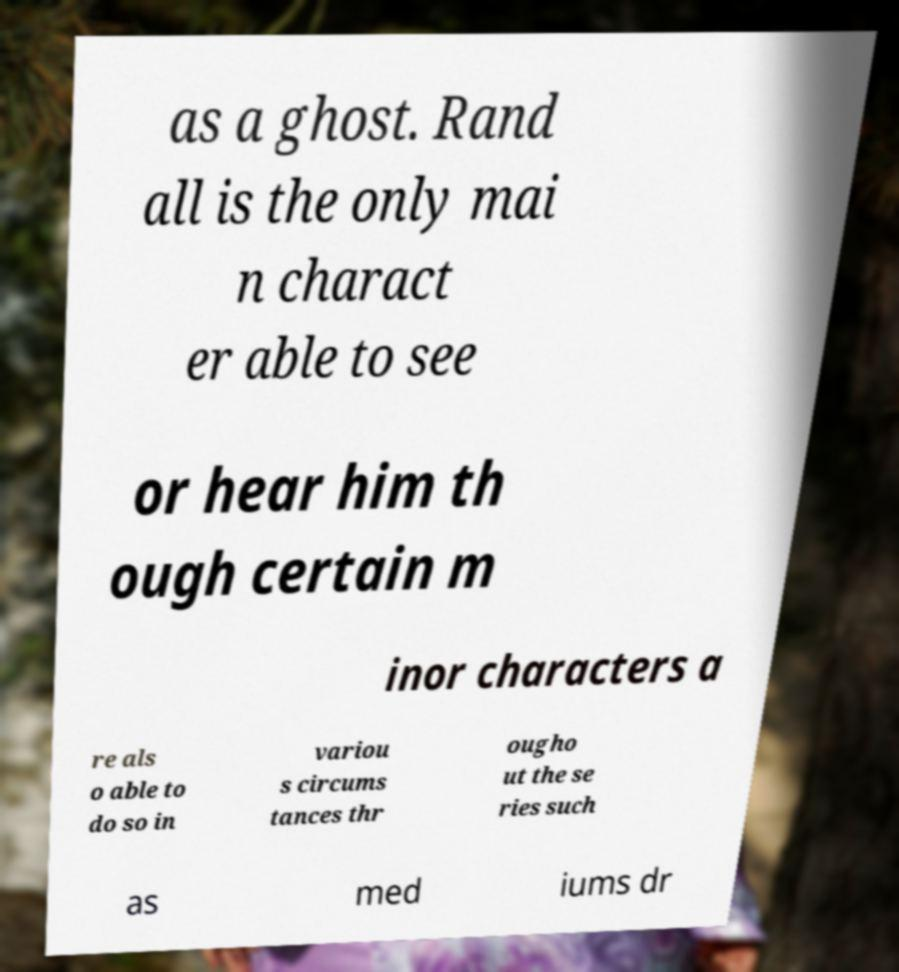Please read and relay the text visible in this image. What does it say? as a ghost. Rand all is the only mai n charact er able to see or hear him th ough certain m inor characters a re als o able to do so in variou s circums tances thr ougho ut the se ries such as med iums dr 